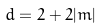<formula> <loc_0><loc_0><loc_500><loc_500>d = 2 + 2 | m |</formula> 